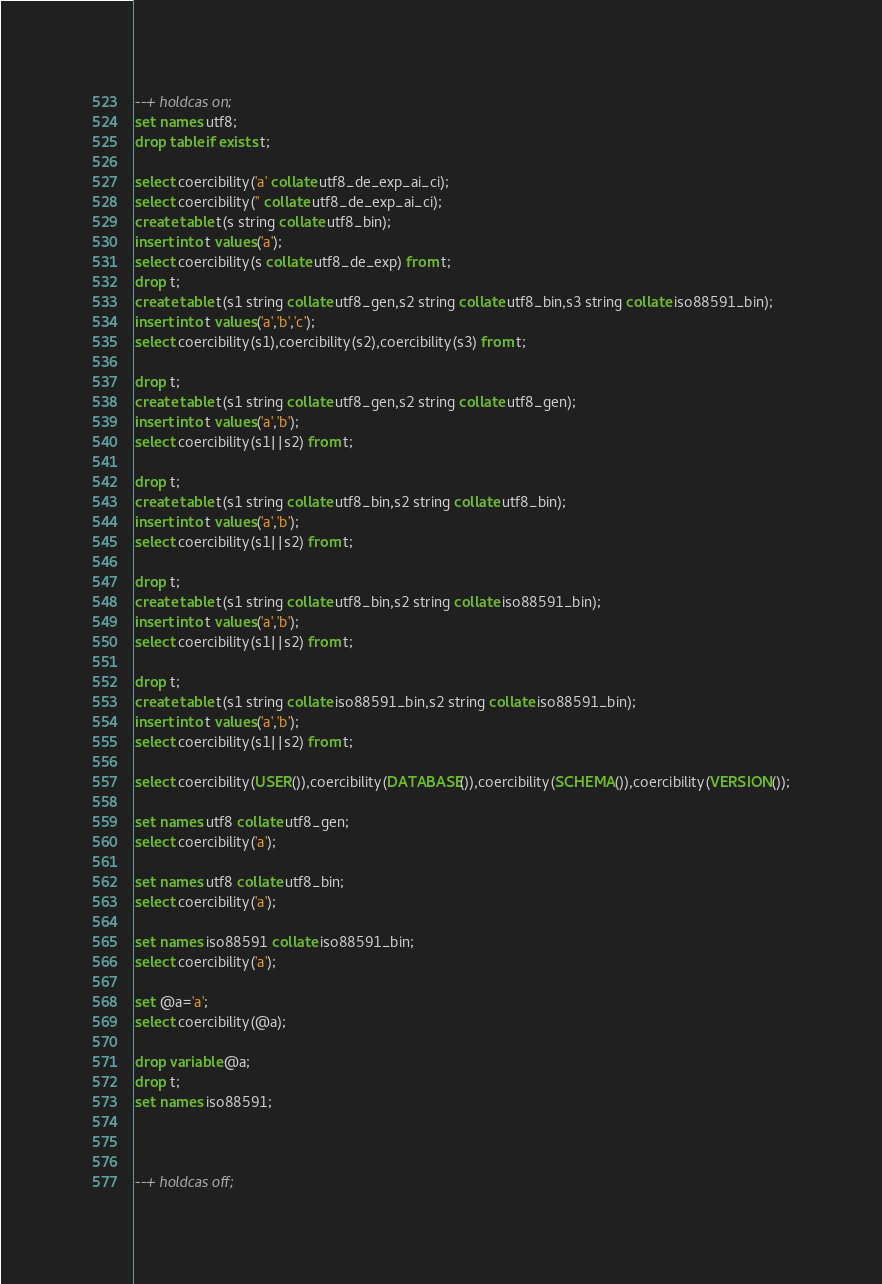<code> <loc_0><loc_0><loc_500><loc_500><_SQL_>--+ holdcas on;
set names utf8;
drop table if exists t;

select coercibility('a' collate utf8_de_exp_ai_ci);
select coercibility('' collate utf8_de_exp_ai_ci);
create table t(s string collate utf8_bin);
insert into t values('a');
select coercibility(s collate utf8_de_exp) from t; 
drop t;
create table t(s1 string collate utf8_gen,s2 string collate utf8_bin,s3 string collate iso88591_bin);
insert into t values('a','b','c');
select coercibility(s1),coercibility(s2),coercibility(s3) from t;

drop t;
create table t(s1 string collate utf8_gen,s2 string collate utf8_gen);
insert into t values('a','b');
select coercibility(s1||s2) from t;

drop t;
create table t(s1 string collate utf8_bin,s2 string collate utf8_bin);
insert into t values('a','b');
select coercibility(s1||s2) from t;

drop t;
create table t(s1 string collate utf8_bin,s2 string collate iso88591_bin);
insert into t values('a','b');
select coercibility(s1||s2) from t;

drop t;
create table t(s1 string collate iso88591_bin,s2 string collate iso88591_bin);
insert into t values('a','b');
select coercibility(s1||s2) from t;

select coercibility(USER()),coercibility(DATABASE()),coercibility(SCHEMA()),coercibility(VERSION());

set names utf8 collate utf8_gen;
select coercibility('a');

set names utf8 collate utf8_bin;
select coercibility('a');

set names iso88591 collate iso88591_bin;
select coercibility('a');

set @a='a';
select coercibility(@a);

drop variable @a;
drop t;
set names iso88591;



--+ holdcas off;
</code> 